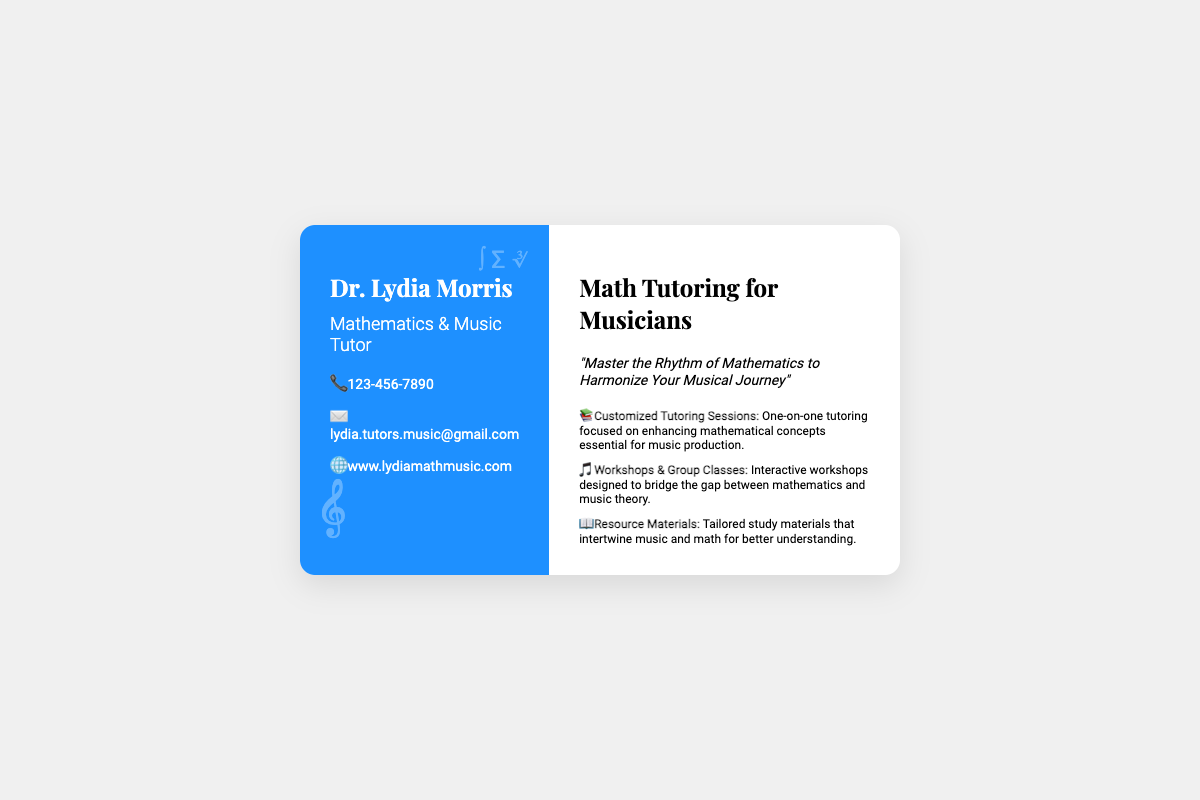What is the name of the tutor? The name of the tutor is mentioned at the top of the card.
Answer: Dr. Lydia Morris What is the contact phone number? The contact phone number is listed in the contact section of the document.
Answer: 123-456-7890 What is the email address for contacting the tutor? The email address is provided in the contact section of the business card.
Answer: lydia.tutors.music@gmail.com What type of tutor is Dr. Lydia Morris? This question relates to the professional title given on the business card.
Answer: Mathematics & Music Tutor What is one service offered by the tutor? A list of services is provided on the right side of the business card.
Answer: Customized Tutoring Sessions What is the motto on the card? The motto summarizes the tutoring philosophy and is prominently displayed on the card.
Answer: "Master the Rhythm of Mathematics to Harmonize Your Musical Journey" In what area does the tutor specialize? The tutoring focus area is implied through the title and the motto on the business card.
Answer: Music Production How many sections does the business card have? The business card is divided into clearly defined sections, which can be counted.
Answer: 2 What is the website for more information? The website is included in the contact details on the business card.
Answer: www.lydiamathmusic.com 